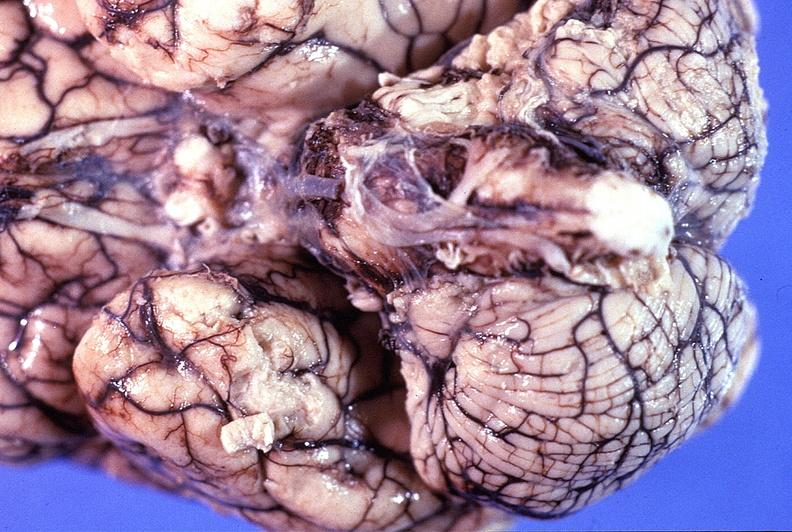what does this image show?
Answer the question using a single word or phrase. Normal brain 